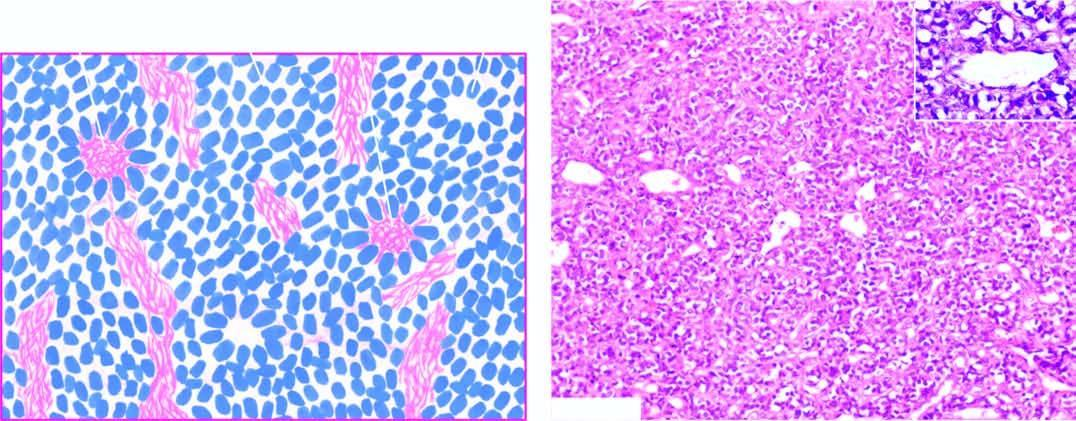re a few homerwright 's pseudorosettes also present?
Answer the question using a single word or phrase. Yes 